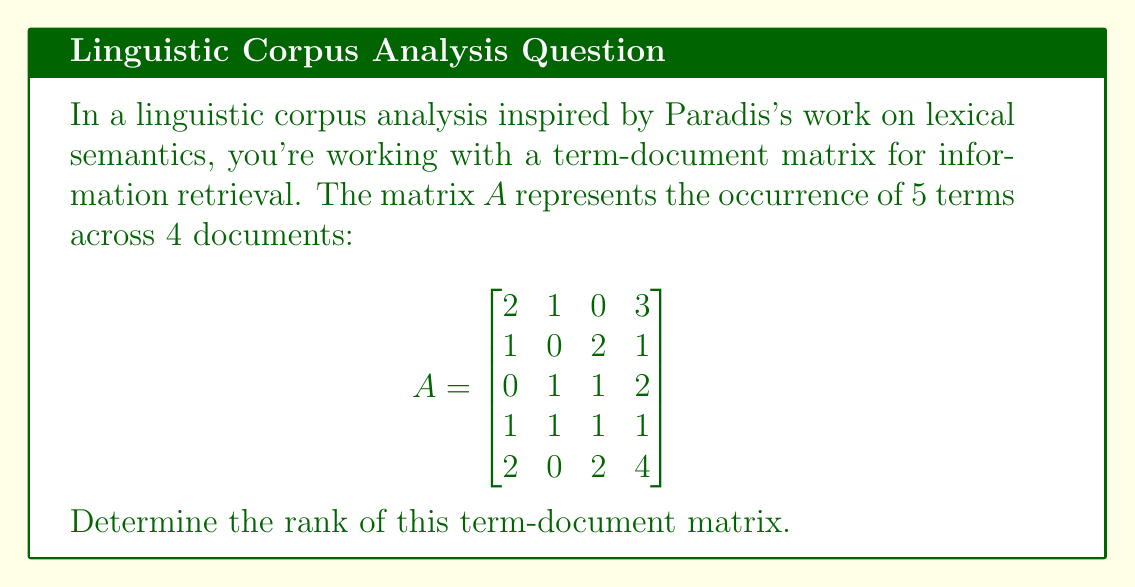Show me your answer to this math problem. To determine the rank of the term-document matrix $A$, we need to find the number of linearly independent rows or columns. We can do this by transforming the matrix into row echelon form using Gaussian elimination.

Step 1: The first row is already non-zero, so we keep it as is.

Step 2: Use the first row to eliminate the first column in the rows below:

$$\begin{bmatrix}
2 & 1 & 0 & 3 \\
0 & -\frac{1}{2} & 2 & -\frac{1}{2} \\
0 & 1 & 1 & 2 \\
0 & \frac{1}{2} & 1 & -\frac{1}{2} \\
0 & -1 & 2 & 1
\end{bmatrix}$$

Step 3: The second row is non-zero, so we keep it. Use it to eliminate the second column in the rows below:

$$\begin{bmatrix}
2 & 1 & 0 & 3 \\
0 & -\frac{1}{2} & 2 & -\frac{1}{2} \\
0 & 0 & -3 & \frac{5}{2} \\
0 & 0 & 0 & -\frac{1}{4} \\
0 & 0 & 0 & \frac{3}{2}
\end{bmatrix}$$

Step 4: The third row is non-zero, so we keep it. Use it to eliminate the third column in the rows below:

$$\begin{bmatrix}
2 & 1 & 0 & 3 \\
0 & -\frac{1}{2} & 2 & -\frac{1}{2} \\
0 & 0 & -3 & \frac{5}{2} \\
0 & 0 & 0 & -\frac{1}{4} \\
0 & 0 & 0 & \frac{3}{2}
\end{bmatrix}$$

The matrix is now in row echelon form. The rank of the matrix is equal to the number of non-zero rows, which is 4.

This result indicates that there are 4 linearly independent rows or columns in the original term-document matrix. In the context of information retrieval and Paradis's work on lexical semantics, this suggests that the matrix captures 4 distinct semantic dimensions or topics across the documents and terms analyzed.
Answer: The rank of the term-document matrix is 4. 